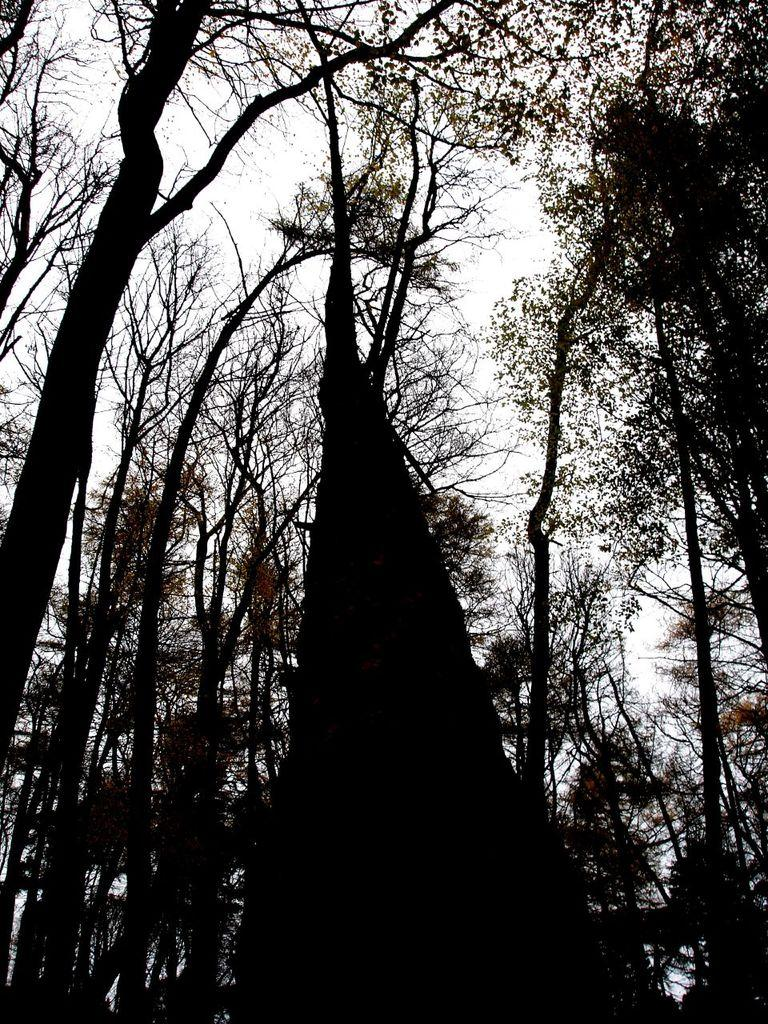What is the color scheme of the image? The image is a black and white picture. What type of natural elements can be seen in the image? There are trees in the image. What part of the natural environment is visible in the image? The sky is visible in the image. How many mice are playing during recess in the image? There are no mice or any indication of recess in the image. 